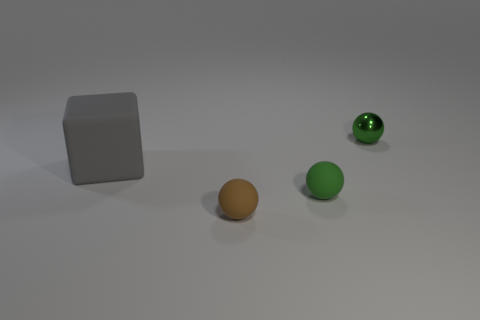There is a green ball in front of the large gray rubber object; how many small matte balls are in front of it?
Offer a very short reply. 1. How many other things are there of the same size as the green metal object?
Provide a succinct answer. 2. There is another thing that is the same color as the shiny object; what is its size?
Provide a short and direct response. Small. There is a tiny green object in front of the cube; is it the same shape as the small green metallic object?
Provide a succinct answer. Yes. There is a sphere behind the large object; what is its material?
Your answer should be compact. Metal. Are there any tiny brown things that have the same material as the big gray block?
Ensure brevity in your answer.  Yes. How big is the green matte sphere?
Provide a short and direct response. Small. How many gray things are metallic things or rubber cubes?
Offer a terse response. 1. What number of other rubber things have the same shape as the green rubber thing?
Ensure brevity in your answer.  1. How many metal objects are the same size as the gray matte thing?
Your response must be concise. 0. 